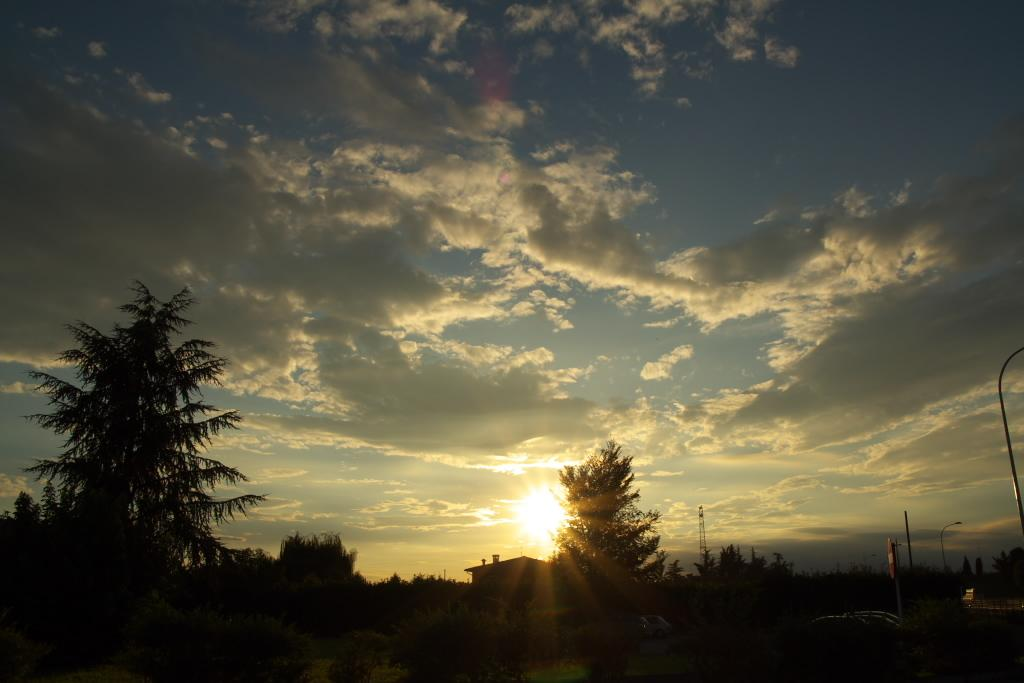What can be seen in the sky in the image? The sky is visible in the image, and clouds and the sun are present. What type of natural elements can be seen in the image? Trees are present in the image. What man-made structures are visible in the image? Poles, sign boards, and at least one building are visible in the image. How many birds can be seen flying in the image? There are no birds visible in the image. What color is the eye of the frog in the image? There is no frog present in the image. 